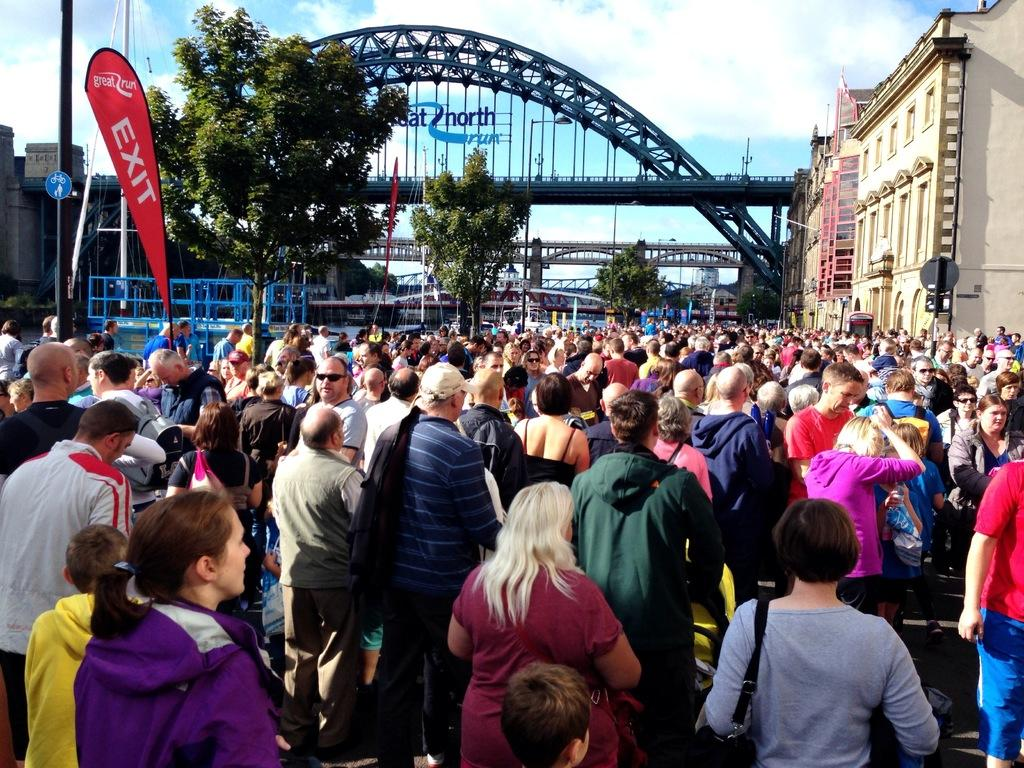How many people are in the image? There is a group of people in the image, but the exact number cannot be determined from the provided facts. What structures are present in the image? There are bridges, poles, boards, buildings, and advertising flags in the image. What type of vegetation is visible in the image? There are trees in the image. What is visible in the background of the image? The sky is visible in the background of the image. What type of skirt is being worn by the trees in the image? There are no skirts present in the image, as the trees are not wearing any clothing. How many hands are visible in the image? There is no mention of hands in the provided facts, so it cannot be determined how many hands are visible in the image. 